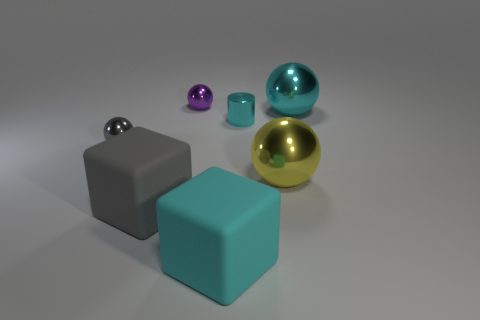There is a cyan ball that is the same material as the big yellow object; what size is it?
Make the answer very short. Large. How many cyan objects have the same shape as the small purple object?
Your answer should be compact. 1. How many objects are either small shiny things in front of the tiny cyan metallic object or cyan things that are right of the cyan rubber block?
Your answer should be compact. 3. There is a big matte cube that is on the left side of the cyan matte object; how many small cyan shiny cylinders are to the right of it?
Your answer should be very brief. 1. There is a large object on the left side of the purple object; does it have the same shape as the matte thing right of the purple metallic object?
Your response must be concise. Yes. There is a matte object that is the same color as the small cylinder; what shape is it?
Make the answer very short. Cube. Are there any yellow cylinders made of the same material as the purple sphere?
Offer a very short reply. No. What number of shiny things are either small spheres or yellow balls?
Ensure brevity in your answer.  3. The small thing that is on the left side of the gray rubber thing that is on the left side of the big yellow thing is what shape?
Your answer should be very brief. Sphere. Is the number of cyan shiny things on the left side of the large yellow shiny sphere less than the number of metallic spheres?
Keep it short and to the point. Yes. 